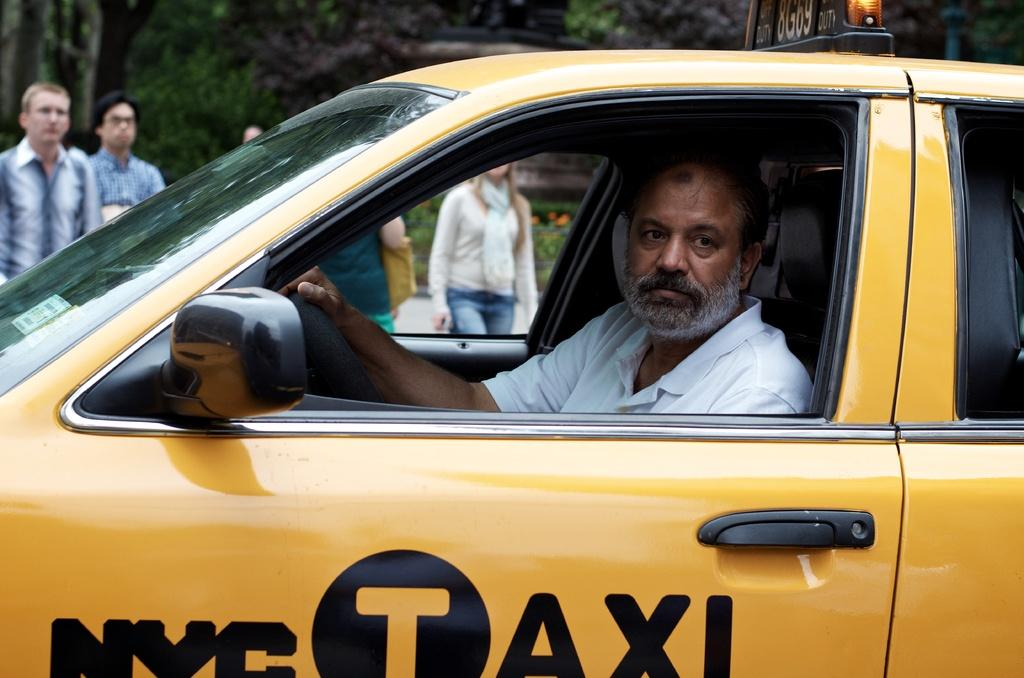<image>
Relay a brief, clear account of the picture shown. A man with a beard is driving a yellow cab that says NYC Taxi. 